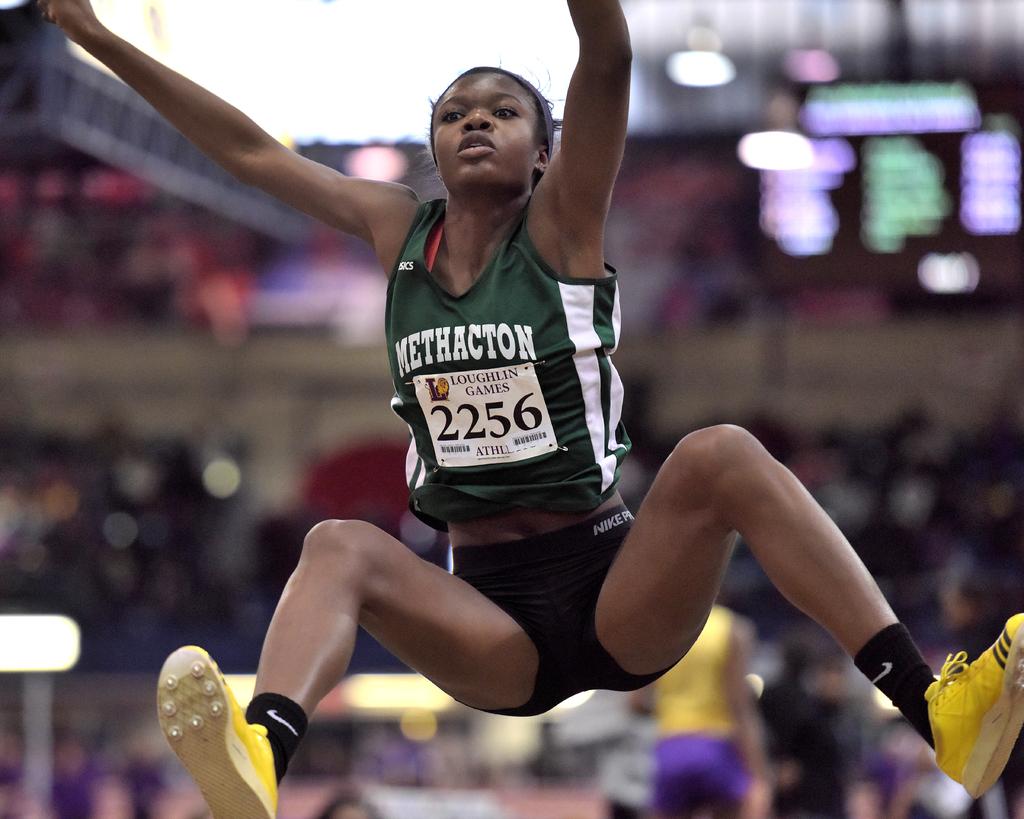What number is this athlete?
Offer a very short reply. 2256. 